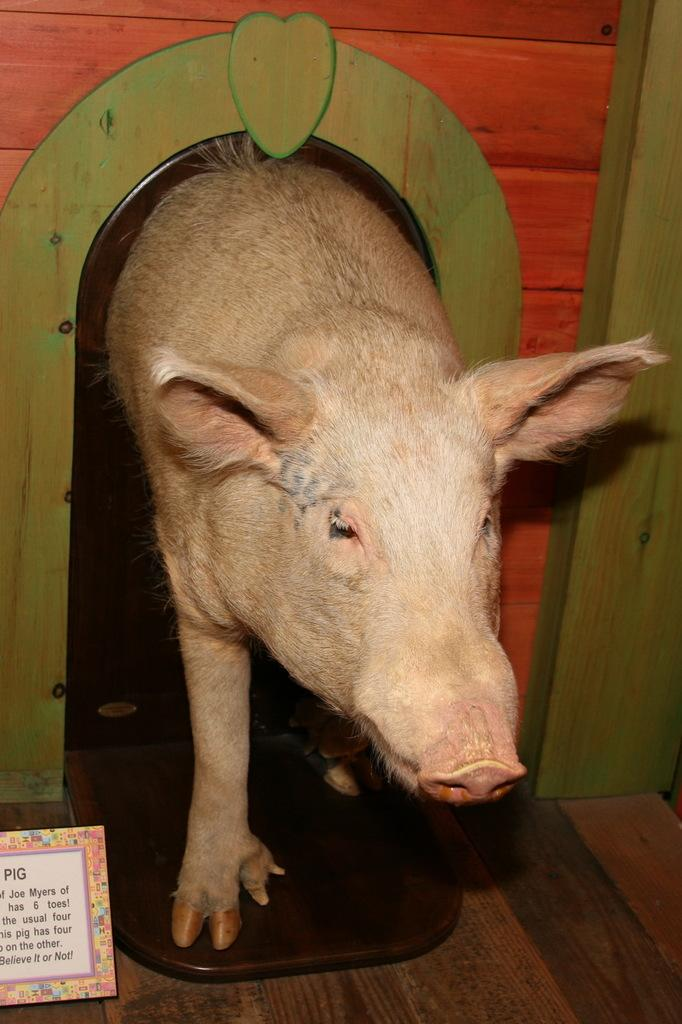What animal is present in the image? There is a pig in the image. Where is the pig coming from? The pig is coming from a kennel. What can be seen on the floor in the image? There is a small hoarding on the floor. What color is the wall in the background of the image? The wall in the background of the image is red. What type of offer is the pig making to the train in the image? There is no train present in the image, and the pig is not making any offers. 